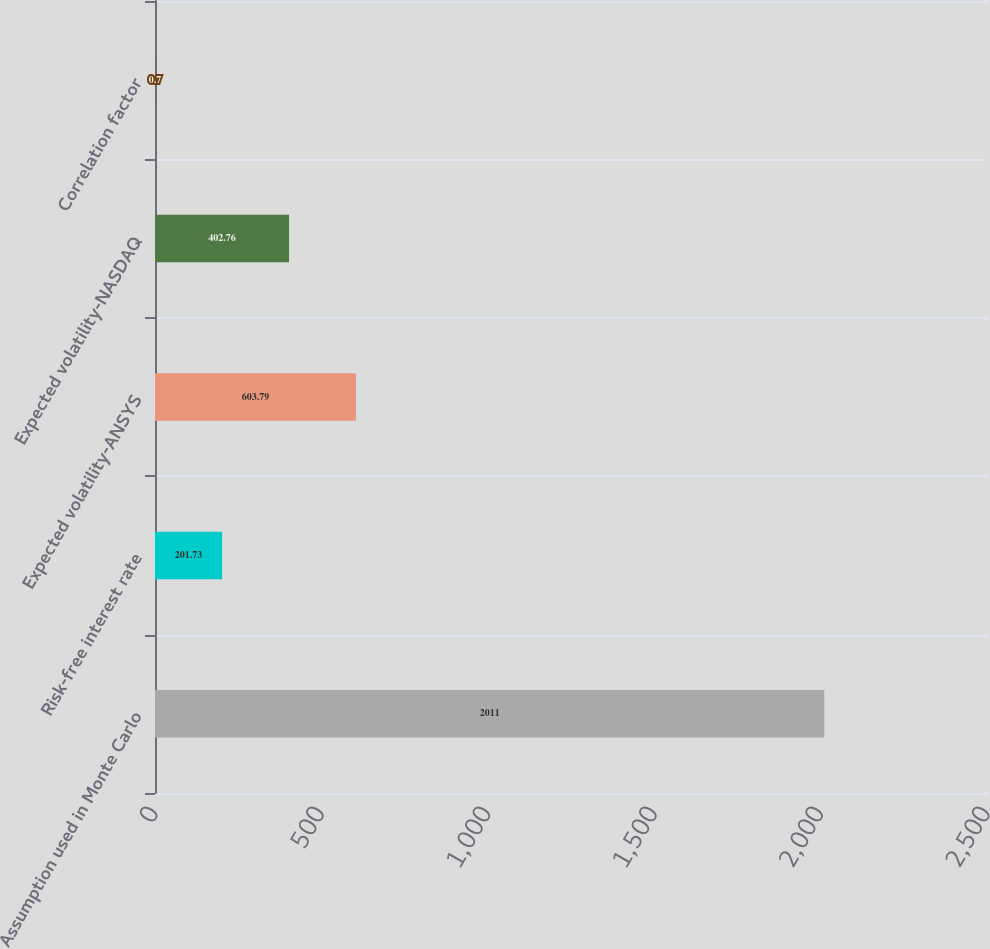Convert chart. <chart><loc_0><loc_0><loc_500><loc_500><bar_chart><fcel>Assumption used in Monte Carlo<fcel>Risk-free interest rate<fcel>Expected volatility-ANSYS<fcel>Expected volatility-NASDAQ<fcel>Correlation factor<nl><fcel>2011<fcel>201.73<fcel>603.79<fcel>402.76<fcel>0.7<nl></chart> 